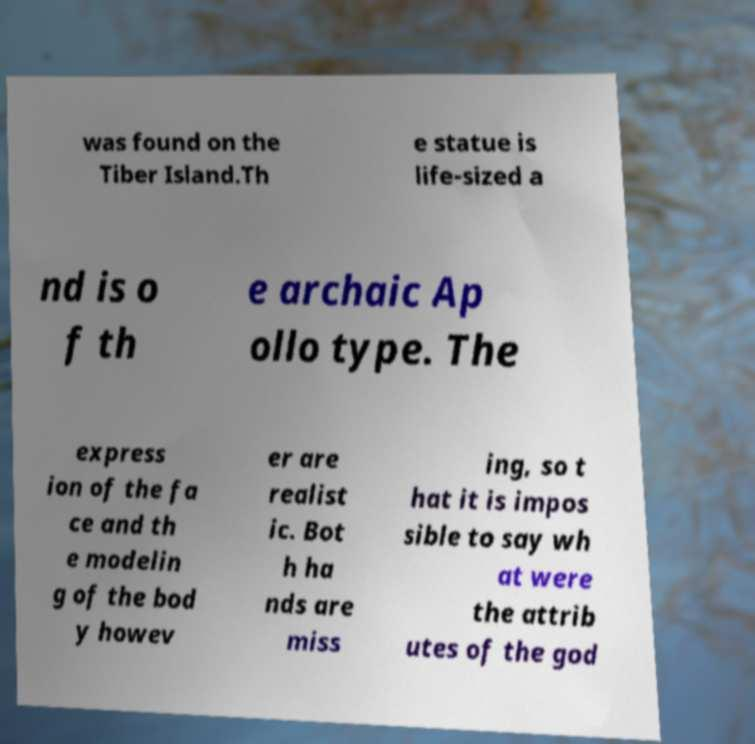What messages or text are displayed in this image? I need them in a readable, typed format. was found on the Tiber Island.Th e statue is life-sized a nd is o f th e archaic Ap ollo type. The express ion of the fa ce and th e modelin g of the bod y howev er are realist ic. Bot h ha nds are miss ing, so t hat it is impos sible to say wh at were the attrib utes of the god 